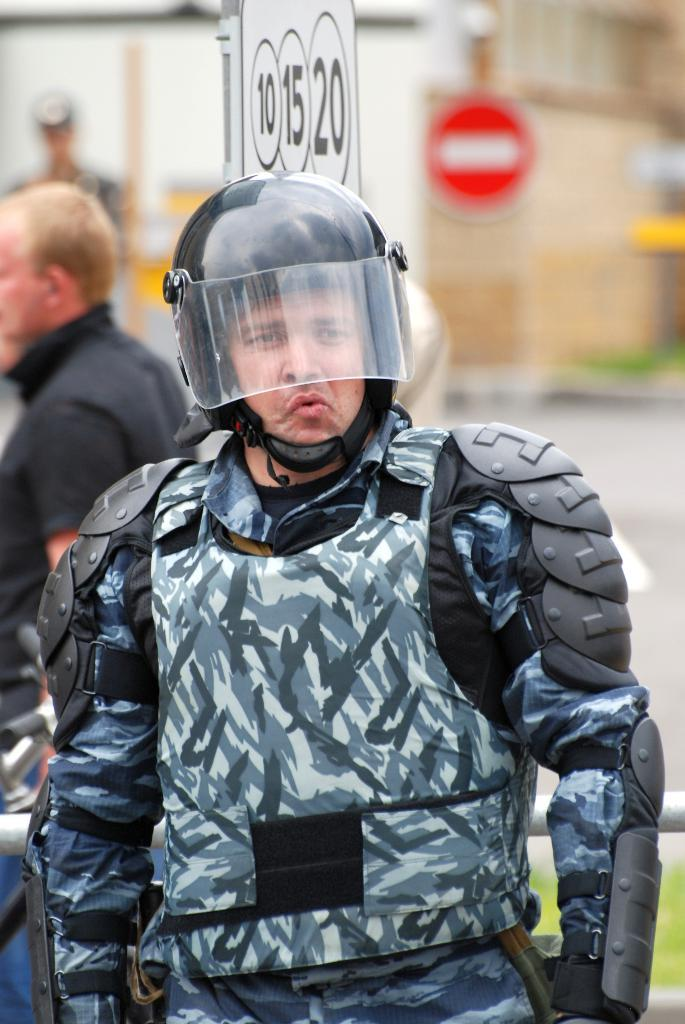What is the person in the image wearing on their head? The person is wearing a black color helmet. Can you describe the person in the background of the image? There is a man standing in the background of the image. What is present in the background of the image besides the man? There is a white color board in the background of the image. What type of structure can be seen in the image? There is a building visible in the image. What type of wave is depicted on the person's elbow in the image? There is no wave depicted on the person's elbow in the image, as they are wearing a helmet and no part of their arm is visible. 